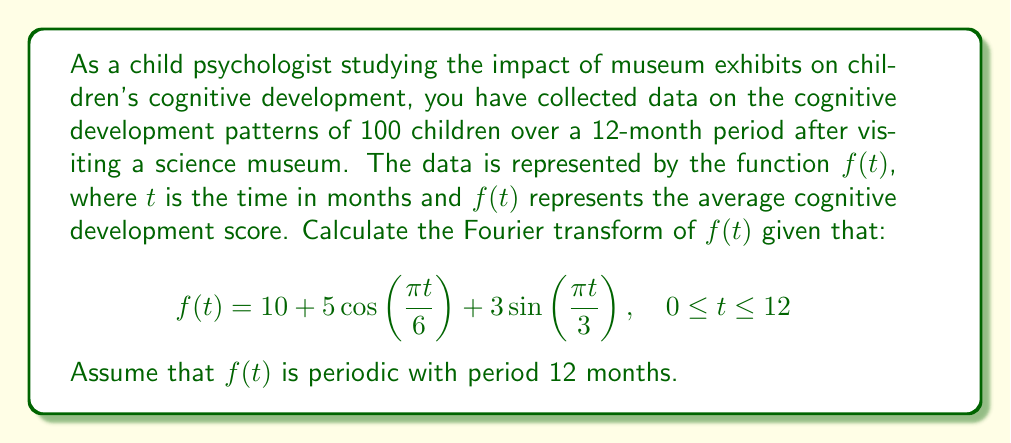What is the answer to this math problem? To compute the Fourier transform of $f(t)$, we need to follow these steps:

1) The Fourier transform of a function $f(t)$ is defined as:

   $$F(\omega) = \int_{-\infty}^{\infty} f(t) e^{-i\omega t} dt$$

2) Given that $f(t)$ is periodic with period 12, we can use the Fourier series representation. The Fourier transform of a periodic function is a series of delta functions at the harmonic frequencies.

3) Let's break down $f(t)$ into its components:
   
   $f(t) = 10 + 5\cos(\frac{\pi t}{6}) + 3\sin(\frac{\pi t}{3})$

4) The Fourier transform of a constant is a delta function at zero frequency:
   
   $\mathcal{F}\{10\} = 10 \cdot 2\pi \delta(\omega)$

5) For the cosine term:
   
   $\mathcal{F}\{5\cos(\frac{\pi t}{6})\} = 5\pi[\delta(\omega - \frac{\pi}{6}) + \delta(\omega + \frac{\pi}{6})]$

6) For the sine term:
   
   $\mathcal{F}\{3\sin(\frac{\pi t}{3})\} = 3\pi i[\delta(\omega - \frac{\pi}{3}) - \delta(\omega + \frac{\pi}{3})]$

7) Combining all terms:

   $$F(\omega) = 20\pi \delta(\omega) + 5\pi[\delta(\omega - \frac{\pi}{6}) + \delta(\omega + \frac{\pi}{6})] + 3\pi i[\delta(\omega - \frac{\pi}{3}) - \delta(\omega + \frac{\pi}{3})]$$

This is the Fourier transform of the given cognitive development pattern function.
Answer: $$F(\omega) = 20\pi \delta(\omega) + 5\pi[\delta(\omega - \frac{\pi}{6}) + \delta(\omega + \frac{\pi}{6})] + 3\pi i[\delta(\omega - \frac{\pi}{3}) - \delta(\omega + \frac{\pi}{3})]$$ 